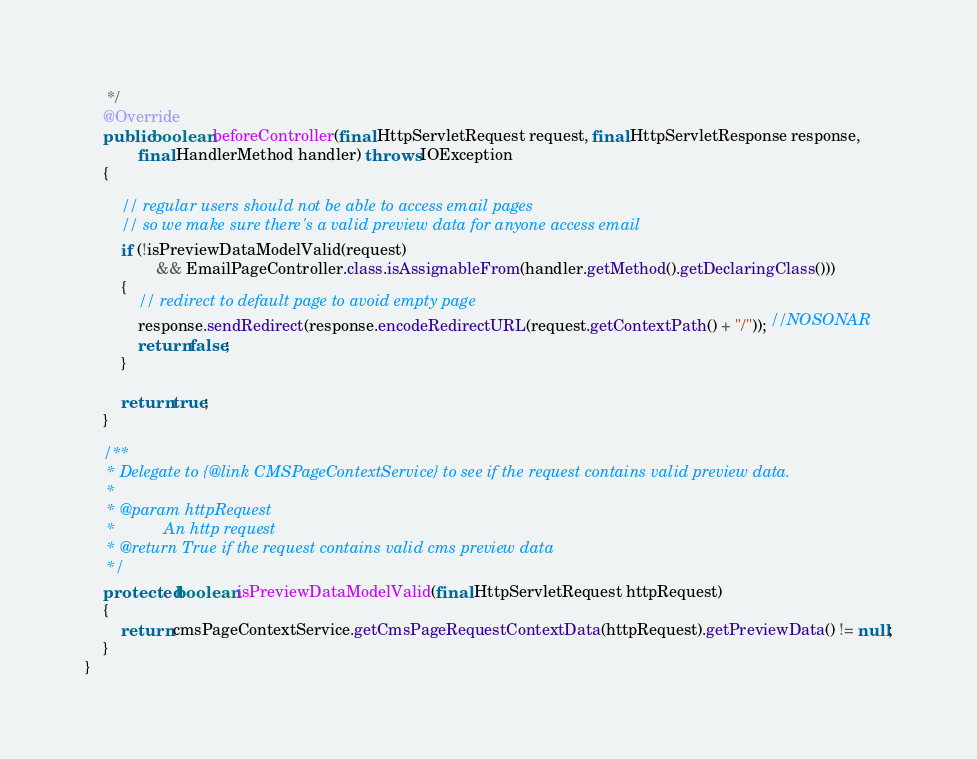<code> <loc_0><loc_0><loc_500><loc_500><_Java_>	 */
	@Override
	public boolean beforeController(final HttpServletRequest request, final HttpServletResponse response,
			final HandlerMethod handler) throws IOException
	{

		// regular users should not be able to access email pages
		// so we make sure there's a valid preview data for anyone access email
		if (!isPreviewDataModelValid(request)
				&& EmailPageController.class.isAssignableFrom(handler.getMethod().getDeclaringClass()))
		{
			// redirect to default page to avoid empty page
			response.sendRedirect(response.encodeRedirectURL(request.getContextPath() + "/")); //NOSONAR
			return false;
		}

		return true;
	}

	/**
	 * Delegate to {@link CMSPageContextService} to see if the request contains valid preview data.
	 *
	 * @param httpRequest
	 *           An http request
	 * @return True if the request contains valid cms preview data
	 */
	protected boolean isPreviewDataModelValid(final HttpServletRequest httpRequest)
	{
		return cmsPageContextService.getCmsPageRequestContextData(httpRequest).getPreviewData() != null;
	}
}
</code> 